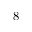<formula> <loc_0><loc_0><loc_500><loc_500>8</formula> 